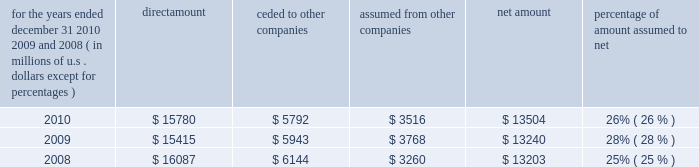S c h e d u l e i v ace limited and subsidiaries s u p p l e m e n t a l i n f o r m a t i o n c o n c e r n i n g r e i n s u r a n c e premiums earned for the years ended december 31 , 2010 , 2009 , and 2008 ( in millions of u.s .
Dollars , except for percentages ) direct amount ceded to companies assumed from other companies net amount percentage of amount assumed to .

In 2010 what was the ratio of the value of the direct amount of the premiums to the amount ceded to other companies? 
Computations: (15780 / 5792)
Answer: 2.72445. 